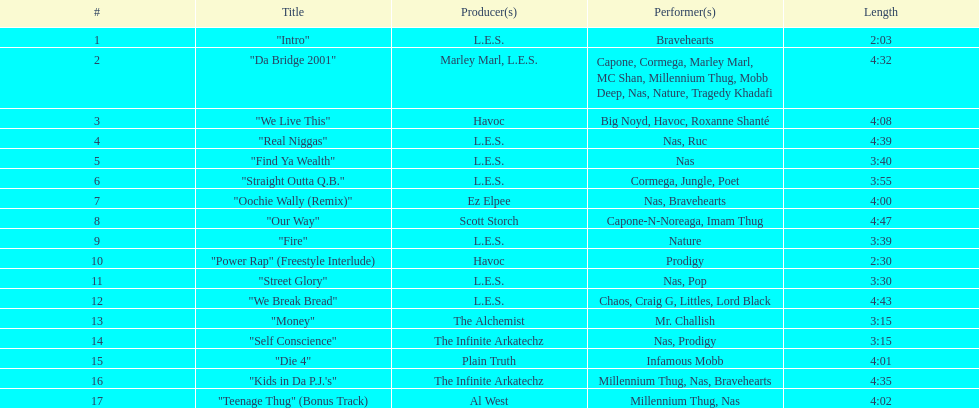Which song was played prior to "fire"? "Our Way". 